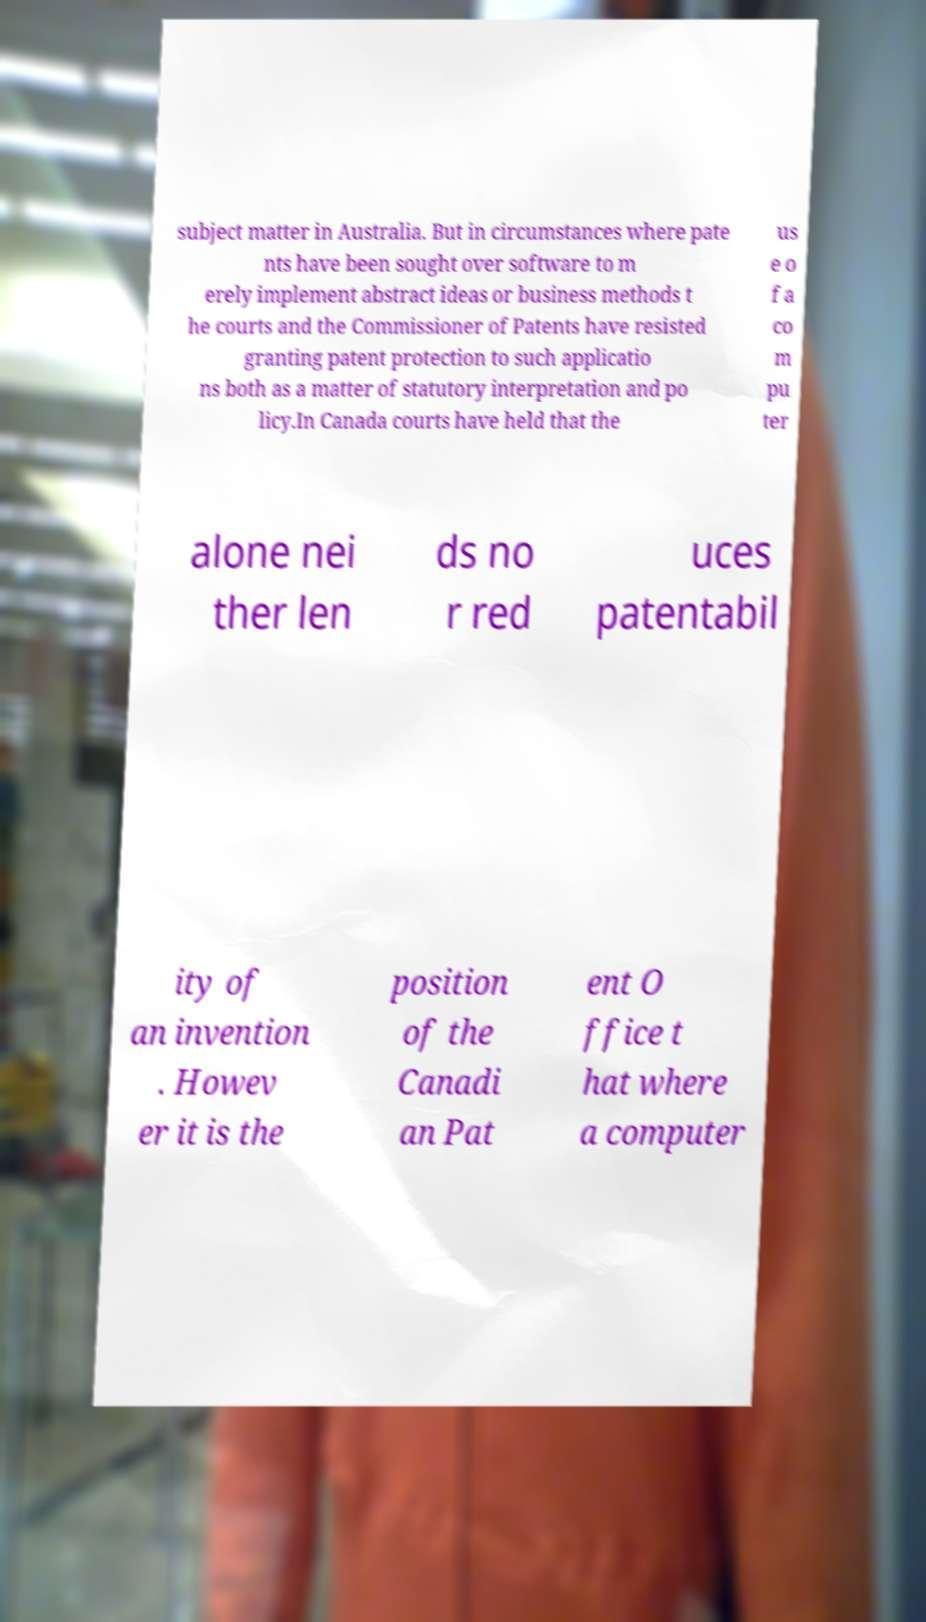Could you assist in decoding the text presented in this image and type it out clearly? subject matter in Australia. But in circumstances where pate nts have been sought over software to m erely implement abstract ideas or business methods t he courts and the Commissioner of Patents have resisted granting patent protection to such applicatio ns both as a matter of statutory interpretation and po licy.In Canada courts have held that the us e o f a co m pu ter alone nei ther len ds no r red uces patentabil ity of an invention . Howev er it is the position of the Canadi an Pat ent O ffice t hat where a computer 